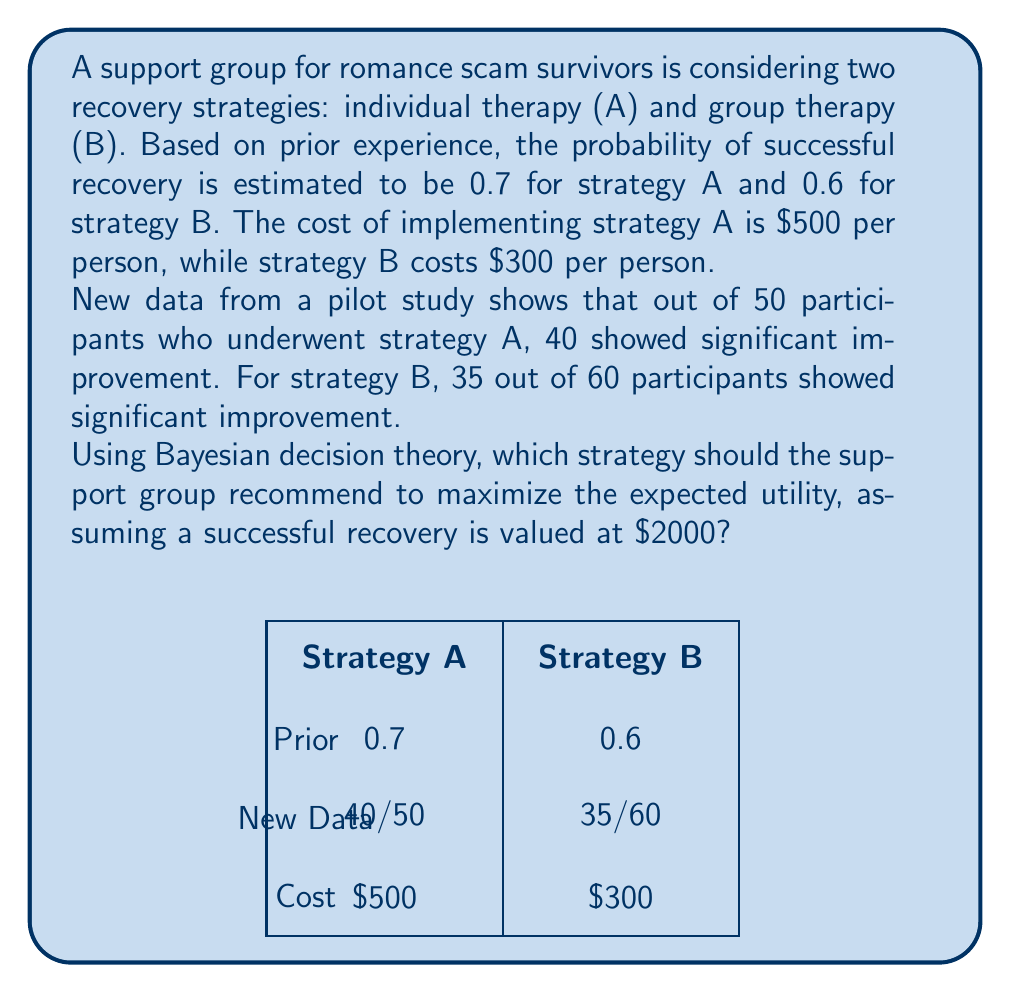Show me your answer to this math problem. Let's approach this problem step-by-step using Bayesian decision theory:

1) First, we need to update our prior probabilities using the new data. We'll use Bayes' theorem:

   $P(Success|Data) = \frac{P(Data|Success) \cdot P(Success)}{P(Data)}$

2) For Strategy A:
   $P(Success_A|Data) = \frac{P(40 out of 50|Success_A) \cdot 0.7}{P(40 out of 50)}$

   We can calculate this using the binomial distribution:
   $P(Success_A|Data) = \frac{\binom{50}{40}0.7^{40}0.3^{10} \cdot 0.7}{\binom{50}{40}0.7^{40}0.3^{10} \cdot 0.7 + \binom{50}{40}0.3^{40}0.7^{10} \cdot 0.3}$

   $P(Success_A|Data) \approx 0.9404$

3) For Strategy B:
   $P(Success_B|Data) = \frac{\binom{60}{35}0.6^{35}0.4^{25} \cdot 0.6}{\binom{60}{35}0.6^{35}0.4^{25} \cdot 0.6 + \binom{60}{35}0.4^{35}0.6^{25} \cdot 0.4}$

   $P(Success_B|Data) \approx 0.5912$

4) Now, let's calculate the expected utility for each strategy:

   For Strategy A:
   $E(U_A) = 0.9404 \cdot 2000 - 500 = 1380.80$

   For Strategy B:
   $E(U_B) = 0.5912 \cdot 2000 - 300 = 882.40$

5) The strategy with the higher expected utility should be recommended.
Answer: Strategy A (individual therapy) with an expected utility of $1380.80 